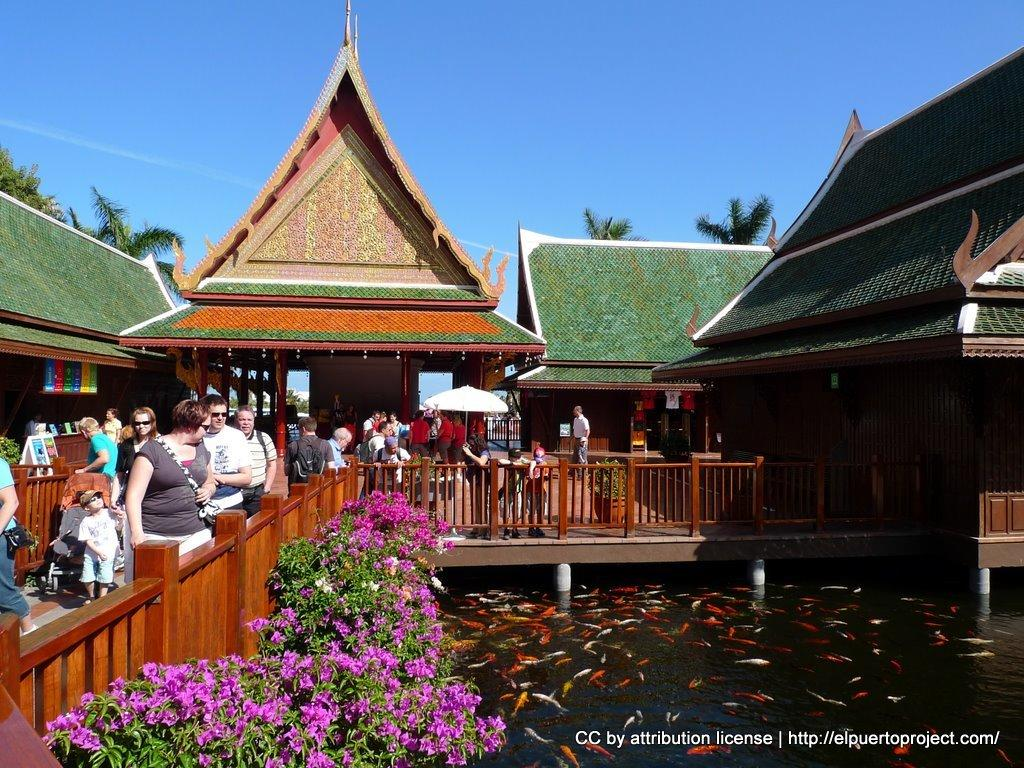How many people can be seen in the image? There are people in the image, but the exact number is not specified. What is the surface beneath the people's feet? There is a floor visible in the image. What type of barrier is present in the image? There is fencing in the image. What type of structures are visible in the image? There are buildings in the image. What type of vegetation is present in the image? Trees, plants, and flowers are visible in the image. What type of water feature is present in the image? There is water visible in the image, and fishes are present in the water. What type of establishments can be seen in the image? There are stores in the image. What type of signage is visible in the image? Posters are visible in the image. What can be seen in the sky in the image? The sky is visible in the image. Can you see a plane flying in the image? There is no mention of a plane in the image, so it cannot be confirmed. Are there any fangs visible on the people in the image? There is no mention of fangs in the image, so it cannot be confirmed. 